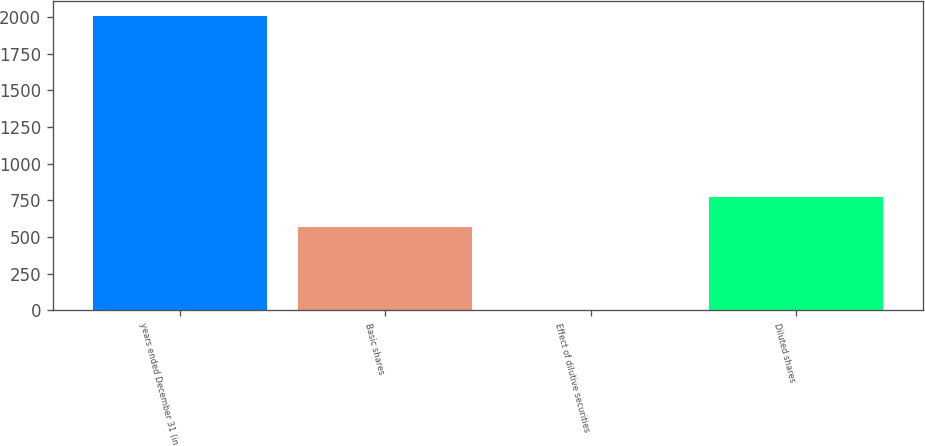<chart> <loc_0><loc_0><loc_500><loc_500><bar_chart><fcel>years ended December 31 (in<fcel>Basic shares<fcel>Effect of dilutive securities<fcel>Diluted shares<nl><fcel>2011<fcel>569<fcel>4<fcel>769.7<nl></chart> 